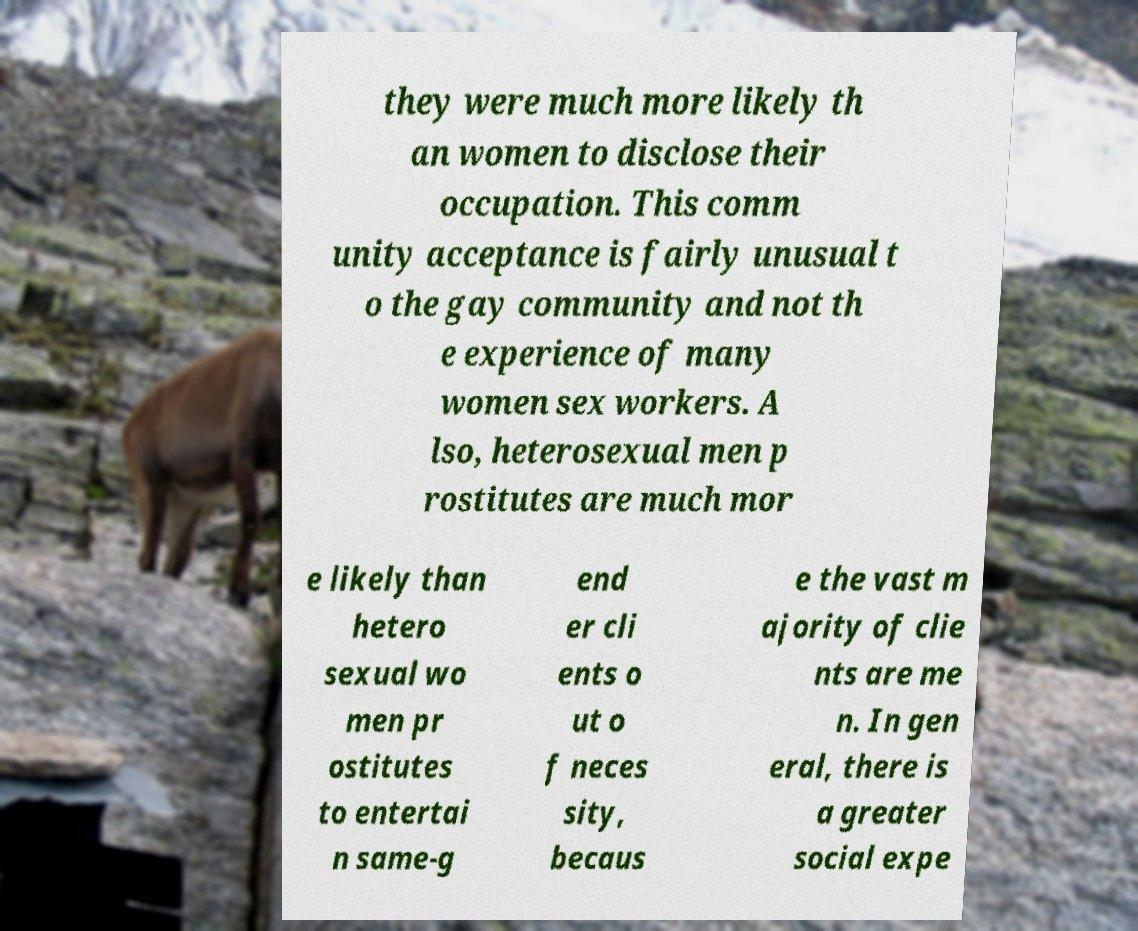What messages or text are displayed in this image? I need them in a readable, typed format. they were much more likely th an women to disclose their occupation. This comm unity acceptance is fairly unusual t o the gay community and not th e experience of many women sex workers. A lso, heterosexual men p rostitutes are much mor e likely than hetero sexual wo men pr ostitutes to entertai n same-g end er cli ents o ut o f neces sity, becaus e the vast m ajority of clie nts are me n. In gen eral, there is a greater social expe 